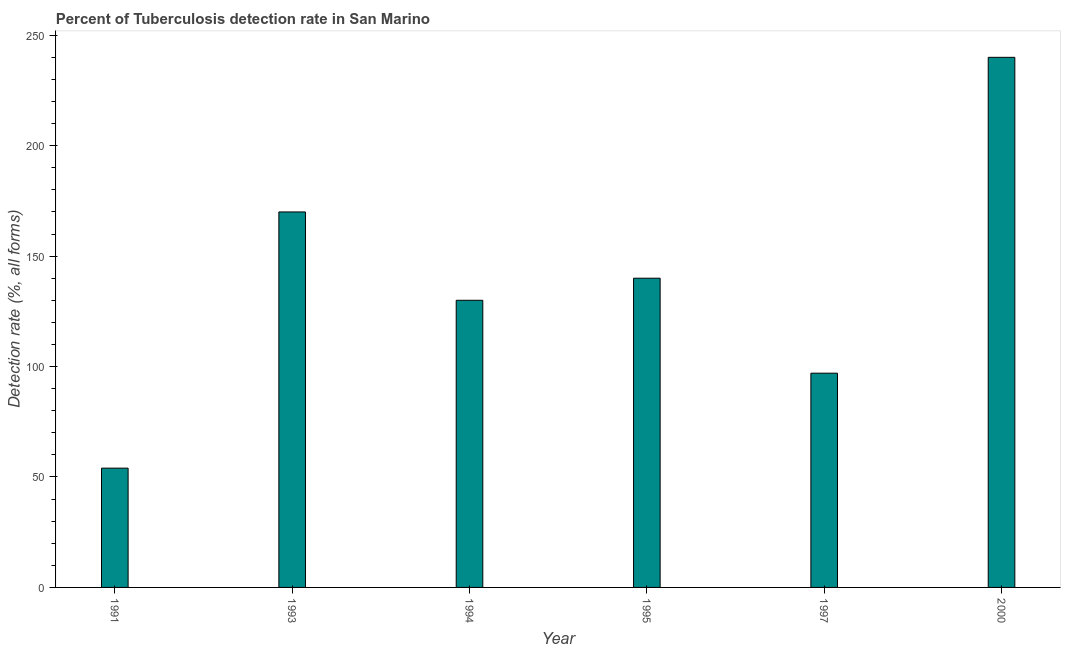What is the title of the graph?
Keep it short and to the point. Percent of Tuberculosis detection rate in San Marino. What is the label or title of the X-axis?
Your answer should be compact. Year. What is the label or title of the Y-axis?
Give a very brief answer. Detection rate (%, all forms). What is the detection rate of tuberculosis in 2000?
Provide a succinct answer. 240. Across all years, what is the maximum detection rate of tuberculosis?
Make the answer very short. 240. Across all years, what is the minimum detection rate of tuberculosis?
Provide a short and direct response. 54. In which year was the detection rate of tuberculosis minimum?
Your answer should be very brief. 1991. What is the sum of the detection rate of tuberculosis?
Make the answer very short. 831. What is the difference between the detection rate of tuberculosis in 1994 and 1995?
Give a very brief answer. -10. What is the average detection rate of tuberculosis per year?
Make the answer very short. 138. What is the median detection rate of tuberculosis?
Your answer should be compact. 135. In how many years, is the detection rate of tuberculosis greater than 50 %?
Keep it short and to the point. 6. Do a majority of the years between 1991 and 1993 (inclusive) have detection rate of tuberculosis greater than 30 %?
Offer a very short reply. Yes. What is the ratio of the detection rate of tuberculosis in 1993 to that in 1994?
Keep it short and to the point. 1.31. Is the detection rate of tuberculosis in 1995 less than that in 1997?
Your answer should be very brief. No. What is the difference between the highest and the lowest detection rate of tuberculosis?
Ensure brevity in your answer.  186. In how many years, is the detection rate of tuberculosis greater than the average detection rate of tuberculosis taken over all years?
Provide a succinct answer. 3. Are all the bars in the graph horizontal?
Your answer should be very brief. No. Are the values on the major ticks of Y-axis written in scientific E-notation?
Your answer should be very brief. No. What is the Detection rate (%, all forms) of 1991?
Your answer should be very brief. 54. What is the Detection rate (%, all forms) of 1993?
Your answer should be very brief. 170. What is the Detection rate (%, all forms) of 1994?
Keep it short and to the point. 130. What is the Detection rate (%, all forms) in 1995?
Make the answer very short. 140. What is the Detection rate (%, all forms) of 1997?
Give a very brief answer. 97. What is the Detection rate (%, all forms) of 2000?
Offer a very short reply. 240. What is the difference between the Detection rate (%, all forms) in 1991 and 1993?
Keep it short and to the point. -116. What is the difference between the Detection rate (%, all forms) in 1991 and 1994?
Provide a succinct answer. -76. What is the difference between the Detection rate (%, all forms) in 1991 and 1995?
Provide a succinct answer. -86. What is the difference between the Detection rate (%, all forms) in 1991 and 1997?
Ensure brevity in your answer.  -43. What is the difference between the Detection rate (%, all forms) in 1991 and 2000?
Your answer should be compact. -186. What is the difference between the Detection rate (%, all forms) in 1993 and 1995?
Make the answer very short. 30. What is the difference between the Detection rate (%, all forms) in 1993 and 1997?
Your answer should be compact. 73. What is the difference between the Detection rate (%, all forms) in 1993 and 2000?
Give a very brief answer. -70. What is the difference between the Detection rate (%, all forms) in 1994 and 1997?
Give a very brief answer. 33. What is the difference between the Detection rate (%, all forms) in 1994 and 2000?
Make the answer very short. -110. What is the difference between the Detection rate (%, all forms) in 1995 and 1997?
Your answer should be very brief. 43. What is the difference between the Detection rate (%, all forms) in 1995 and 2000?
Provide a succinct answer. -100. What is the difference between the Detection rate (%, all forms) in 1997 and 2000?
Provide a succinct answer. -143. What is the ratio of the Detection rate (%, all forms) in 1991 to that in 1993?
Keep it short and to the point. 0.32. What is the ratio of the Detection rate (%, all forms) in 1991 to that in 1994?
Offer a terse response. 0.41. What is the ratio of the Detection rate (%, all forms) in 1991 to that in 1995?
Make the answer very short. 0.39. What is the ratio of the Detection rate (%, all forms) in 1991 to that in 1997?
Your answer should be very brief. 0.56. What is the ratio of the Detection rate (%, all forms) in 1991 to that in 2000?
Your response must be concise. 0.23. What is the ratio of the Detection rate (%, all forms) in 1993 to that in 1994?
Provide a short and direct response. 1.31. What is the ratio of the Detection rate (%, all forms) in 1993 to that in 1995?
Provide a succinct answer. 1.21. What is the ratio of the Detection rate (%, all forms) in 1993 to that in 1997?
Your response must be concise. 1.75. What is the ratio of the Detection rate (%, all forms) in 1993 to that in 2000?
Give a very brief answer. 0.71. What is the ratio of the Detection rate (%, all forms) in 1994 to that in 1995?
Give a very brief answer. 0.93. What is the ratio of the Detection rate (%, all forms) in 1994 to that in 1997?
Your answer should be compact. 1.34. What is the ratio of the Detection rate (%, all forms) in 1994 to that in 2000?
Offer a very short reply. 0.54. What is the ratio of the Detection rate (%, all forms) in 1995 to that in 1997?
Keep it short and to the point. 1.44. What is the ratio of the Detection rate (%, all forms) in 1995 to that in 2000?
Offer a very short reply. 0.58. What is the ratio of the Detection rate (%, all forms) in 1997 to that in 2000?
Your answer should be compact. 0.4. 